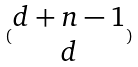<formula> <loc_0><loc_0><loc_500><loc_500>( \begin{matrix} d + n - 1 \\ d \end{matrix} )</formula> 